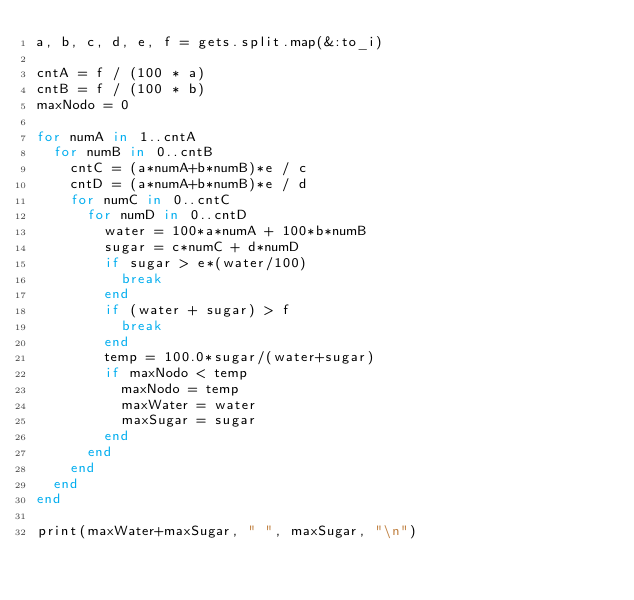<code> <loc_0><loc_0><loc_500><loc_500><_Ruby_>a, b, c, d, e, f = gets.split.map(&:to_i)

cntA = f / (100 * a)
cntB = f / (100 * b)
maxNodo = 0

for numA in 1..cntA
	for numB in 0..cntB
		cntC = (a*numA+b*numB)*e / c
		cntD = (a*numA+b*numB)*e / d
		for numC in 0..cntC
			for numD in 0..cntD
				water = 100*a*numA + 100*b*numB
				sugar = c*numC + d*numD
				if sugar > e*(water/100)
					break
				end
				if (water + sugar) > f
					break
				end
				temp = 100.0*sugar/(water+sugar)
				if maxNodo < temp
					maxNodo = temp
					maxWater = water
					maxSugar = sugar
				end
			end
		end
	end
end

print(maxWater+maxSugar, " ", maxSugar, "\n")</code> 